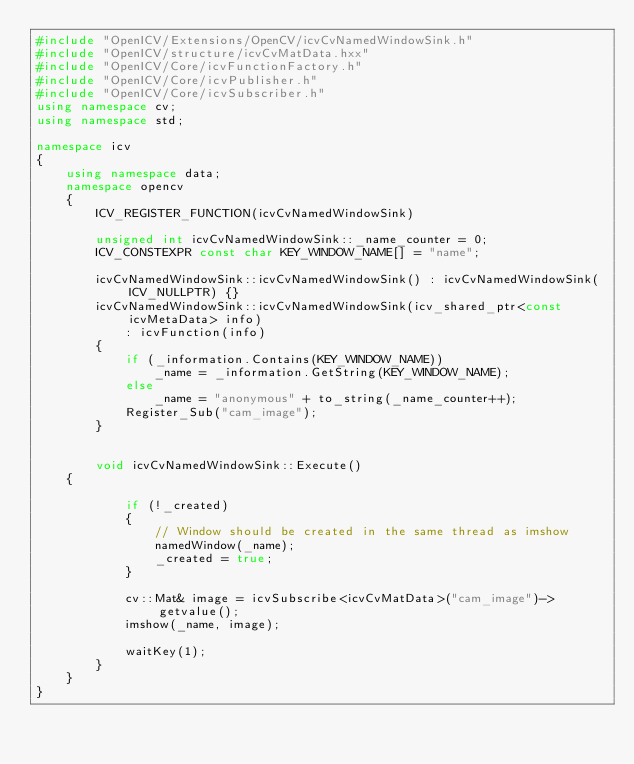<code> <loc_0><loc_0><loc_500><loc_500><_C++_>#include "OpenICV/Extensions/OpenCV/icvCvNamedWindowSink.h"
#include "OpenICV/structure/icvCvMatData.hxx"
#include "OpenICV/Core/icvFunctionFactory.h"
#include "OpenICV/Core/icvPublisher.h"
#include "OpenICV/Core/icvSubscriber.h"
using namespace cv;
using namespace std;

namespace icv
{
    using namespace data;
    namespace opencv
    {
        ICV_REGISTER_FUNCTION(icvCvNamedWindowSink)

        unsigned int icvCvNamedWindowSink::_name_counter = 0;
        ICV_CONSTEXPR const char KEY_WINDOW_NAME[] = "name";

        icvCvNamedWindowSink::icvCvNamedWindowSink() : icvCvNamedWindowSink(ICV_NULLPTR) {}
        icvCvNamedWindowSink::icvCvNamedWindowSink(icv_shared_ptr<const icvMetaData> info)
            : icvFunction(info)
        {
            if (_information.Contains(KEY_WINDOW_NAME))
                _name = _information.GetString(KEY_WINDOW_NAME);
            else
                _name = "anonymous" + to_string(_name_counter++);
            Register_Sub("cam_image");
        }


        void icvCvNamedWindowSink::Execute()
    {

            if (!_created)
            {
                // Window should be created in the same thread as imshow
                namedWindow(_name);
                _created = true;
            }
    
            cv::Mat& image = icvSubscribe<icvCvMatData>("cam_image")->getvalue();
            imshow(_name, image);

            waitKey(1);
        }
    }
}</code> 